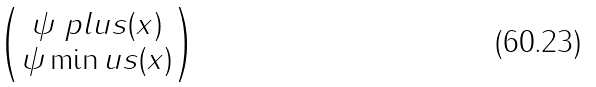Convert formula to latex. <formula><loc_0><loc_0><loc_500><loc_500>\begin{pmatrix} \psi \ p l u s ( x ) \\ \psi \min u s ( x ) \end{pmatrix}</formula> 